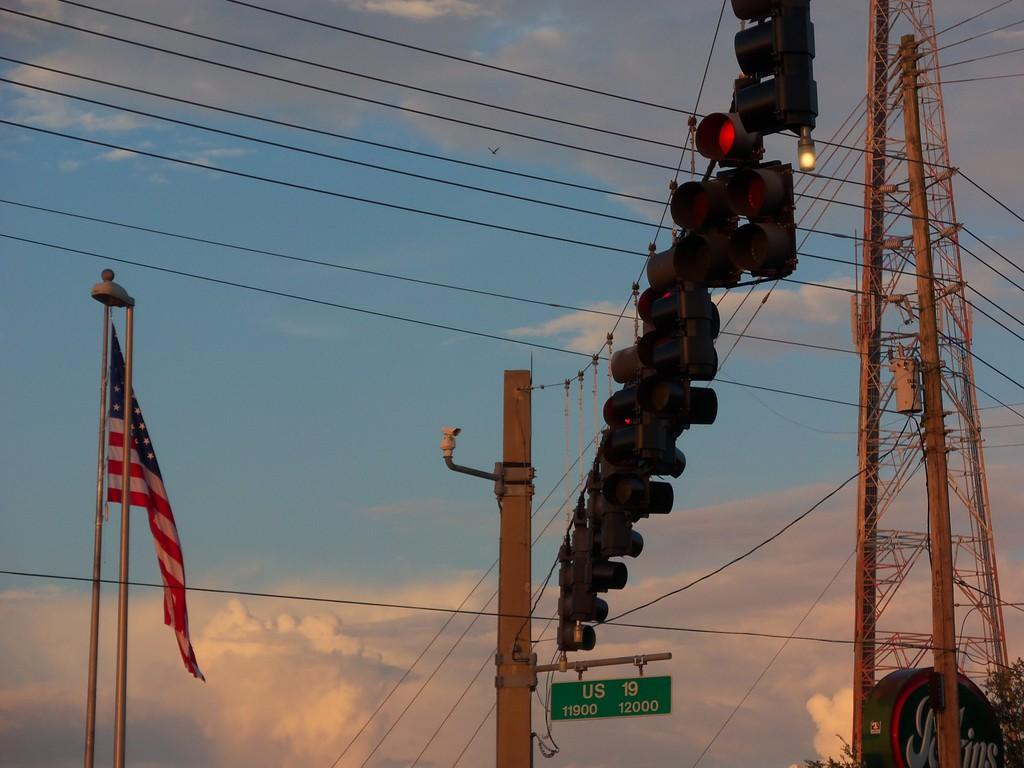<image>
Offer a succinct explanation of the picture presented. A street sign for US highway 19 with an American flag to the left. 